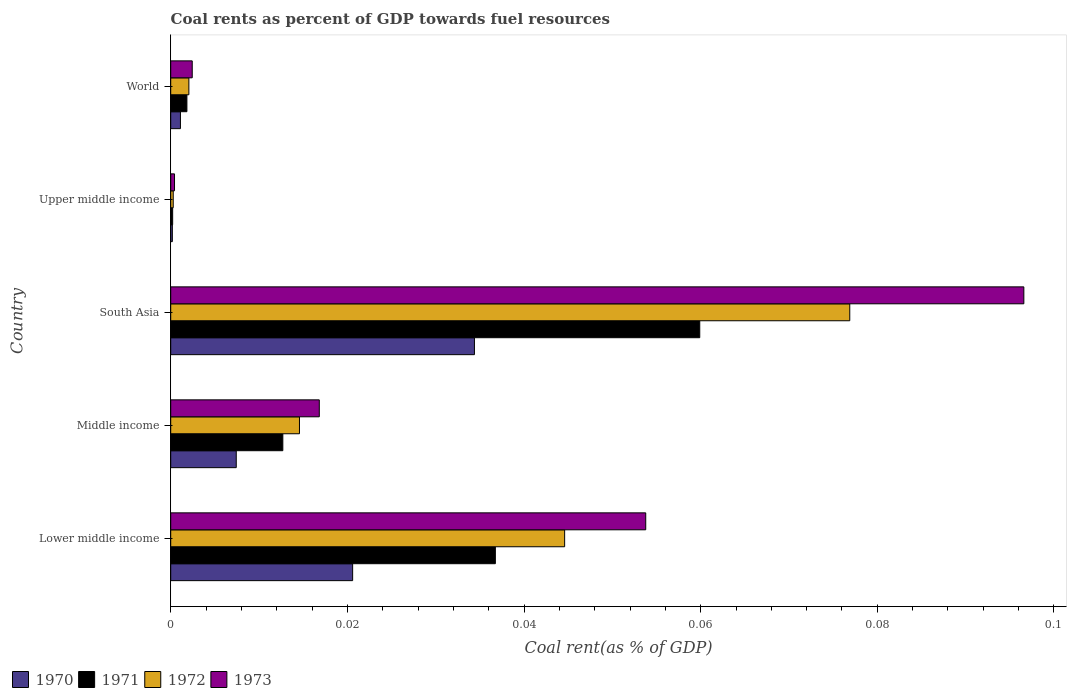How many groups of bars are there?
Ensure brevity in your answer.  5. Are the number of bars per tick equal to the number of legend labels?
Ensure brevity in your answer.  Yes. What is the label of the 4th group of bars from the top?
Offer a terse response. Middle income. In how many cases, is the number of bars for a given country not equal to the number of legend labels?
Keep it short and to the point. 0. What is the coal rent in 1972 in Lower middle income?
Your answer should be very brief. 0.04. Across all countries, what is the maximum coal rent in 1971?
Keep it short and to the point. 0.06. Across all countries, what is the minimum coal rent in 1972?
Your answer should be very brief. 0. In which country was the coal rent in 1973 maximum?
Provide a succinct answer. South Asia. In which country was the coal rent in 1971 minimum?
Offer a terse response. Upper middle income. What is the total coal rent in 1971 in the graph?
Keep it short and to the point. 0.11. What is the difference between the coal rent in 1972 in Lower middle income and that in Upper middle income?
Keep it short and to the point. 0.04. What is the difference between the coal rent in 1971 in World and the coal rent in 1970 in Upper middle income?
Your answer should be very brief. 0. What is the average coal rent in 1973 per country?
Your answer should be compact. 0.03. What is the difference between the coal rent in 1973 and coal rent in 1970 in Lower middle income?
Make the answer very short. 0.03. In how many countries, is the coal rent in 1971 greater than 0.08 %?
Ensure brevity in your answer.  0. What is the ratio of the coal rent in 1972 in Lower middle income to that in Middle income?
Ensure brevity in your answer.  3.06. Is the coal rent in 1973 in South Asia less than that in World?
Offer a very short reply. No. Is the difference between the coal rent in 1973 in South Asia and World greater than the difference between the coal rent in 1970 in South Asia and World?
Give a very brief answer. Yes. What is the difference between the highest and the second highest coal rent in 1971?
Ensure brevity in your answer.  0.02. What is the difference between the highest and the lowest coal rent in 1970?
Keep it short and to the point. 0.03. In how many countries, is the coal rent in 1971 greater than the average coal rent in 1971 taken over all countries?
Give a very brief answer. 2. Is it the case that in every country, the sum of the coal rent in 1970 and coal rent in 1973 is greater than the sum of coal rent in 1971 and coal rent in 1972?
Give a very brief answer. No. What does the 1st bar from the top in South Asia represents?
Your answer should be very brief. 1973. What does the 4th bar from the bottom in Middle income represents?
Your response must be concise. 1973. Is it the case that in every country, the sum of the coal rent in 1971 and coal rent in 1973 is greater than the coal rent in 1972?
Keep it short and to the point. Yes. What is the difference between two consecutive major ticks on the X-axis?
Your answer should be very brief. 0.02. Are the values on the major ticks of X-axis written in scientific E-notation?
Provide a short and direct response. No. Does the graph contain grids?
Offer a terse response. No. What is the title of the graph?
Offer a very short reply. Coal rents as percent of GDP towards fuel resources. What is the label or title of the X-axis?
Give a very brief answer. Coal rent(as % of GDP). What is the Coal rent(as % of GDP) of 1970 in Lower middle income?
Give a very brief answer. 0.02. What is the Coal rent(as % of GDP) of 1971 in Lower middle income?
Offer a terse response. 0.04. What is the Coal rent(as % of GDP) in 1972 in Lower middle income?
Provide a short and direct response. 0.04. What is the Coal rent(as % of GDP) of 1973 in Lower middle income?
Give a very brief answer. 0.05. What is the Coal rent(as % of GDP) of 1970 in Middle income?
Provide a succinct answer. 0.01. What is the Coal rent(as % of GDP) in 1971 in Middle income?
Your response must be concise. 0.01. What is the Coal rent(as % of GDP) in 1972 in Middle income?
Keep it short and to the point. 0.01. What is the Coal rent(as % of GDP) in 1973 in Middle income?
Your response must be concise. 0.02. What is the Coal rent(as % of GDP) of 1970 in South Asia?
Provide a short and direct response. 0.03. What is the Coal rent(as % of GDP) of 1971 in South Asia?
Ensure brevity in your answer.  0.06. What is the Coal rent(as % of GDP) of 1972 in South Asia?
Keep it short and to the point. 0.08. What is the Coal rent(as % of GDP) of 1973 in South Asia?
Give a very brief answer. 0.1. What is the Coal rent(as % of GDP) in 1970 in Upper middle income?
Make the answer very short. 0. What is the Coal rent(as % of GDP) of 1971 in Upper middle income?
Provide a succinct answer. 0. What is the Coal rent(as % of GDP) in 1972 in Upper middle income?
Keep it short and to the point. 0. What is the Coal rent(as % of GDP) in 1973 in Upper middle income?
Give a very brief answer. 0. What is the Coal rent(as % of GDP) in 1970 in World?
Offer a terse response. 0. What is the Coal rent(as % of GDP) of 1971 in World?
Ensure brevity in your answer.  0. What is the Coal rent(as % of GDP) of 1972 in World?
Your response must be concise. 0. What is the Coal rent(as % of GDP) of 1973 in World?
Offer a very short reply. 0. Across all countries, what is the maximum Coal rent(as % of GDP) in 1970?
Provide a succinct answer. 0.03. Across all countries, what is the maximum Coal rent(as % of GDP) in 1971?
Your response must be concise. 0.06. Across all countries, what is the maximum Coal rent(as % of GDP) of 1972?
Your answer should be compact. 0.08. Across all countries, what is the maximum Coal rent(as % of GDP) in 1973?
Make the answer very short. 0.1. Across all countries, what is the minimum Coal rent(as % of GDP) in 1970?
Offer a very short reply. 0. Across all countries, what is the minimum Coal rent(as % of GDP) of 1971?
Offer a very short reply. 0. Across all countries, what is the minimum Coal rent(as % of GDP) in 1972?
Offer a very short reply. 0. Across all countries, what is the minimum Coal rent(as % of GDP) of 1973?
Make the answer very short. 0. What is the total Coal rent(as % of GDP) in 1970 in the graph?
Your response must be concise. 0.06. What is the total Coal rent(as % of GDP) of 1971 in the graph?
Your response must be concise. 0.11. What is the total Coal rent(as % of GDP) of 1972 in the graph?
Your response must be concise. 0.14. What is the total Coal rent(as % of GDP) of 1973 in the graph?
Make the answer very short. 0.17. What is the difference between the Coal rent(as % of GDP) in 1970 in Lower middle income and that in Middle income?
Your response must be concise. 0.01. What is the difference between the Coal rent(as % of GDP) in 1971 in Lower middle income and that in Middle income?
Make the answer very short. 0.02. What is the difference between the Coal rent(as % of GDP) of 1973 in Lower middle income and that in Middle income?
Your answer should be compact. 0.04. What is the difference between the Coal rent(as % of GDP) in 1970 in Lower middle income and that in South Asia?
Offer a very short reply. -0.01. What is the difference between the Coal rent(as % of GDP) in 1971 in Lower middle income and that in South Asia?
Make the answer very short. -0.02. What is the difference between the Coal rent(as % of GDP) in 1972 in Lower middle income and that in South Asia?
Provide a succinct answer. -0.03. What is the difference between the Coal rent(as % of GDP) of 1973 in Lower middle income and that in South Asia?
Give a very brief answer. -0.04. What is the difference between the Coal rent(as % of GDP) of 1970 in Lower middle income and that in Upper middle income?
Give a very brief answer. 0.02. What is the difference between the Coal rent(as % of GDP) in 1971 in Lower middle income and that in Upper middle income?
Make the answer very short. 0.04. What is the difference between the Coal rent(as % of GDP) of 1972 in Lower middle income and that in Upper middle income?
Offer a very short reply. 0.04. What is the difference between the Coal rent(as % of GDP) in 1973 in Lower middle income and that in Upper middle income?
Ensure brevity in your answer.  0.05. What is the difference between the Coal rent(as % of GDP) in 1970 in Lower middle income and that in World?
Offer a terse response. 0.02. What is the difference between the Coal rent(as % of GDP) of 1971 in Lower middle income and that in World?
Offer a terse response. 0.03. What is the difference between the Coal rent(as % of GDP) of 1972 in Lower middle income and that in World?
Your answer should be very brief. 0.04. What is the difference between the Coal rent(as % of GDP) in 1973 in Lower middle income and that in World?
Offer a very short reply. 0.05. What is the difference between the Coal rent(as % of GDP) of 1970 in Middle income and that in South Asia?
Offer a very short reply. -0.03. What is the difference between the Coal rent(as % of GDP) in 1971 in Middle income and that in South Asia?
Offer a very short reply. -0.05. What is the difference between the Coal rent(as % of GDP) in 1972 in Middle income and that in South Asia?
Keep it short and to the point. -0.06. What is the difference between the Coal rent(as % of GDP) in 1973 in Middle income and that in South Asia?
Give a very brief answer. -0.08. What is the difference between the Coal rent(as % of GDP) in 1970 in Middle income and that in Upper middle income?
Provide a short and direct response. 0.01. What is the difference between the Coal rent(as % of GDP) of 1971 in Middle income and that in Upper middle income?
Provide a succinct answer. 0.01. What is the difference between the Coal rent(as % of GDP) of 1972 in Middle income and that in Upper middle income?
Your answer should be compact. 0.01. What is the difference between the Coal rent(as % of GDP) of 1973 in Middle income and that in Upper middle income?
Provide a short and direct response. 0.02. What is the difference between the Coal rent(as % of GDP) in 1970 in Middle income and that in World?
Keep it short and to the point. 0.01. What is the difference between the Coal rent(as % of GDP) in 1971 in Middle income and that in World?
Give a very brief answer. 0.01. What is the difference between the Coal rent(as % of GDP) of 1972 in Middle income and that in World?
Your response must be concise. 0.01. What is the difference between the Coal rent(as % of GDP) of 1973 in Middle income and that in World?
Keep it short and to the point. 0.01. What is the difference between the Coal rent(as % of GDP) in 1970 in South Asia and that in Upper middle income?
Your answer should be very brief. 0.03. What is the difference between the Coal rent(as % of GDP) in 1971 in South Asia and that in Upper middle income?
Offer a very short reply. 0.06. What is the difference between the Coal rent(as % of GDP) in 1972 in South Asia and that in Upper middle income?
Your answer should be very brief. 0.08. What is the difference between the Coal rent(as % of GDP) in 1973 in South Asia and that in Upper middle income?
Provide a succinct answer. 0.1. What is the difference between the Coal rent(as % of GDP) of 1970 in South Asia and that in World?
Provide a short and direct response. 0.03. What is the difference between the Coal rent(as % of GDP) of 1971 in South Asia and that in World?
Offer a very short reply. 0.06. What is the difference between the Coal rent(as % of GDP) in 1972 in South Asia and that in World?
Keep it short and to the point. 0.07. What is the difference between the Coal rent(as % of GDP) in 1973 in South Asia and that in World?
Provide a succinct answer. 0.09. What is the difference between the Coal rent(as % of GDP) of 1970 in Upper middle income and that in World?
Your answer should be very brief. -0. What is the difference between the Coal rent(as % of GDP) of 1971 in Upper middle income and that in World?
Your answer should be very brief. -0. What is the difference between the Coal rent(as % of GDP) of 1972 in Upper middle income and that in World?
Offer a terse response. -0. What is the difference between the Coal rent(as % of GDP) of 1973 in Upper middle income and that in World?
Keep it short and to the point. -0. What is the difference between the Coal rent(as % of GDP) in 1970 in Lower middle income and the Coal rent(as % of GDP) in 1971 in Middle income?
Provide a succinct answer. 0.01. What is the difference between the Coal rent(as % of GDP) in 1970 in Lower middle income and the Coal rent(as % of GDP) in 1972 in Middle income?
Keep it short and to the point. 0.01. What is the difference between the Coal rent(as % of GDP) of 1970 in Lower middle income and the Coal rent(as % of GDP) of 1973 in Middle income?
Offer a terse response. 0. What is the difference between the Coal rent(as % of GDP) of 1971 in Lower middle income and the Coal rent(as % of GDP) of 1972 in Middle income?
Provide a succinct answer. 0.02. What is the difference between the Coal rent(as % of GDP) of 1971 in Lower middle income and the Coal rent(as % of GDP) of 1973 in Middle income?
Ensure brevity in your answer.  0.02. What is the difference between the Coal rent(as % of GDP) of 1972 in Lower middle income and the Coal rent(as % of GDP) of 1973 in Middle income?
Give a very brief answer. 0.03. What is the difference between the Coal rent(as % of GDP) in 1970 in Lower middle income and the Coal rent(as % of GDP) in 1971 in South Asia?
Ensure brevity in your answer.  -0.04. What is the difference between the Coal rent(as % of GDP) of 1970 in Lower middle income and the Coal rent(as % of GDP) of 1972 in South Asia?
Offer a terse response. -0.06. What is the difference between the Coal rent(as % of GDP) in 1970 in Lower middle income and the Coal rent(as % of GDP) in 1973 in South Asia?
Provide a short and direct response. -0.08. What is the difference between the Coal rent(as % of GDP) in 1971 in Lower middle income and the Coal rent(as % of GDP) in 1972 in South Asia?
Ensure brevity in your answer.  -0.04. What is the difference between the Coal rent(as % of GDP) in 1971 in Lower middle income and the Coal rent(as % of GDP) in 1973 in South Asia?
Give a very brief answer. -0.06. What is the difference between the Coal rent(as % of GDP) in 1972 in Lower middle income and the Coal rent(as % of GDP) in 1973 in South Asia?
Your answer should be compact. -0.05. What is the difference between the Coal rent(as % of GDP) in 1970 in Lower middle income and the Coal rent(as % of GDP) in 1971 in Upper middle income?
Your response must be concise. 0.02. What is the difference between the Coal rent(as % of GDP) of 1970 in Lower middle income and the Coal rent(as % of GDP) of 1972 in Upper middle income?
Provide a succinct answer. 0.02. What is the difference between the Coal rent(as % of GDP) of 1970 in Lower middle income and the Coal rent(as % of GDP) of 1973 in Upper middle income?
Your answer should be compact. 0.02. What is the difference between the Coal rent(as % of GDP) of 1971 in Lower middle income and the Coal rent(as % of GDP) of 1972 in Upper middle income?
Your answer should be compact. 0.04. What is the difference between the Coal rent(as % of GDP) in 1971 in Lower middle income and the Coal rent(as % of GDP) in 1973 in Upper middle income?
Your answer should be very brief. 0.04. What is the difference between the Coal rent(as % of GDP) of 1972 in Lower middle income and the Coal rent(as % of GDP) of 1973 in Upper middle income?
Your answer should be compact. 0.04. What is the difference between the Coal rent(as % of GDP) in 1970 in Lower middle income and the Coal rent(as % of GDP) in 1971 in World?
Provide a succinct answer. 0.02. What is the difference between the Coal rent(as % of GDP) in 1970 in Lower middle income and the Coal rent(as % of GDP) in 1972 in World?
Provide a short and direct response. 0.02. What is the difference between the Coal rent(as % of GDP) in 1970 in Lower middle income and the Coal rent(as % of GDP) in 1973 in World?
Provide a short and direct response. 0.02. What is the difference between the Coal rent(as % of GDP) in 1971 in Lower middle income and the Coal rent(as % of GDP) in 1972 in World?
Make the answer very short. 0.03. What is the difference between the Coal rent(as % of GDP) of 1971 in Lower middle income and the Coal rent(as % of GDP) of 1973 in World?
Provide a short and direct response. 0.03. What is the difference between the Coal rent(as % of GDP) of 1972 in Lower middle income and the Coal rent(as % of GDP) of 1973 in World?
Keep it short and to the point. 0.04. What is the difference between the Coal rent(as % of GDP) in 1970 in Middle income and the Coal rent(as % of GDP) in 1971 in South Asia?
Offer a terse response. -0.05. What is the difference between the Coal rent(as % of GDP) in 1970 in Middle income and the Coal rent(as % of GDP) in 1972 in South Asia?
Your answer should be very brief. -0.07. What is the difference between the Coal rent(as % of GDP) in 1970 in Middle income and the Coal rent(as % of GDP) in 1973 in South Asia?
Make the answer very short. -0.09. What is the difference between the Coal rent(as % of GDP) of 1971 in Middle income and the Coal rent(as % of GDP) of 1972 in South Asia?
Keep it short and to the point. -0.06. What is the difference between the Coal rent(as % of GDP) of 1971 in Middle income and the Coal rent(as % of GDP) of 1973 in South Asia?
Keep it short and to the point. -0.08. What is the difference between the Coal rent(as % of GDP) in 1972 in Middle income and the Coal rent(as % of GDP) in 1973 in South Asia?
Ensure brevity in your answer.  -0.08. What is the difference between the Coal rent(as % of GDP) in 1970 in Middle income and the Coal rent(as % of GDP) in 1971 in Upper middle income?
Provide a short and direct response. 0.01. What is the difference between the Coal rent(as % of GDP) of 1970 in Middle income and the Coal rent(as % of GDP) of 1972 in Upper middle income?
Offer a very short reply. 0.01. What is the difference between the Coal rent(as % of GDP) in 1970 in Middle income and the Coal rent(as % of GDP) in 1973 in Upper middle income?
Keep it short and to the point. 0.01. What is the difference between the Coal rent(as % of GDP) in 1971 in Middle income and the Coal rent(as % of GDP) in 1972 in Upper middle income?
Ensure brevity in your answer.  0.01. What is the difference between the Coal rent(as % of GDP) of 1971 in Middle income and the Coal rent(as % of GDP) of 1973 in Upper middle income?
Your response must be concise. 0.01. What is the difference between the Coal rent(as % of GDP) in 1972 in Middle income and the Coal rent(as % of GDP) in 1973 in Upper middle income?
Provide a succinct answer. 0.01. What is the difference between the Coal rent(as % of GDP) in 1970 in Middle income and the Coal rent(as % of GDP) in 1971 in World?
Your answer should be compact. 0.01. What is the difference between the Coal rent(as % of GDP) in 1970 in Middle income and the Coal rent(as % of GDP) in 1972 in World?
Your answer should be compact. 0.01. What is the difference between the Coal rent(as % of GDP) in 1970 in Middle income and the Coal rent(as % of GDP) in 1973 in World?
Keep it short and to the point. 0.01. What is the difference between the Coal rent(as % of GDP) of 1971 in Middle income and the Coal rent(as % of GDP) of 1972 in World?
Provide a succinct answer. 0.01. What is the difference between the Coal rent(as % of GDP) in 1971 in Middle income and the Coal rent(as % of GDP) in 1973 in World?
Give a very brief answer. 0.01. What is the difference between the Coal rent(as % of GDP) of 1972 in Middle income and the Coal rent(as % of GDP) of 1973 in World?
Your answer should be very brief. 0.01. What is the difference between the Coal rent(as % of GDP) of 1970 in South Asia and the Coal rent(as % of GDP) of 1971 in Upper middle income?
Your response must be concise. 0.03. What is the difference between the Coal rent(as % of GDP) of 1970 in South Asia and the Coal rent(as % of GDP) of 1972 in Upper middle income?
Your answer should be compact. 0.03. What is the difference between the Coal rent(as % of GDP) of 1970 in South Asia and the Coal rent(as % of GDP) of 1973 in Upper middle income?
Offer a very short reply. 0.03. What is the difference between the Coal rent(as % of GDP) of 1971 in South Asia and the Coal rent(as % of GDP) of 1972 in Upper middle income?
Ensure brevity in your answer.  0.06. What is the difference between the Coal rent(as % of GDP) in 1971 in South Asia and the Coal rent(as % of GDP) in 1973 in Upper middle income?
Keep it short and to the point. 0.06. What is the difference between the Coal rent(as % of GDP) in 1972 in South Asia and the Coal rent(as % of GDP) in 1973 in Upper middle income?
Offer a very short reply. 0.08. What is the difference between the Coal rent(as % of GDP) in 1970 in South Asia and the Coal rent(as % of GDP) in 1971 in World?
Your response must be concise. 0.03. What is the difference between the Coal rent(as % of GDP) of 1970 in South Asia and the Coal rent(as % of GDP) of 1972 in World?
Ensure brevity in your answer.  0.03. What is the difference between the Coal rent(as % of GDP) in 1970 in South Asia and the Coal rent(as % of GDP) in 1973 in World?
Ensure brevity in your answer.  0.03. What is the difference between the Coal rent(as % of GDP) in 1971 in South Asia and the Coal rent(as % of GDP) in 1972 in World?
Keep it short and to the point. 0.06. What is the difference between the Coal rent(as % of GDP) of 1971 in South Asia and the Coal rent(as % of GDP) of 1973 in World?
Ensure brevity in your answer.  0.06. What is the difference between the Coal rent(as % of GDP) of 1972 in South Asia and the Coal rent(as % of GDP) of 1973 in World?
Provide a succinct answer. 0.07. What is the difference between the Coal rent(as % of GDP) of 1970 in Upper middle income and the Coal rent(as % of GDP) of 1971 in World?
Your answer should be very brief. -0. What is the difference between the Coal rent(as % of GDP) of 1970 in Upper middle income and the Coal rent(as % of GDP) of 1972 in World?
Keep it short and to the point. -0. What is the difference between the Coal rent(as % of GDP) of 1970 in Upper middle income and the Coal rent(as % of GDP) of 1973 in World?
Your response must be concise. -0. What is the difference between the Coal rent(as % of GDP) in 1971 in Upper middle income and the Coal rent(as % of GDP) in 1972 in World?
Make the answer very short. -0. What is the difference between the Coal rent(as % of GDP) of 1971 in Upper middle income and the Coal rent(as % of GDP) of 1973 in World?
Provide a succinct answer. -0. What is the difference between the Coal rent(as % of GDP) of 1972 in Upper middle income and the Coal rent(as % of GDP) of 1973 in World?
Give a very brief answer. -0. What is the average Coal rent(as % of GDP) of 1970 per country?
Ensure brevity in your answer.  0.01. What is the average Coal rent(as % of GDP) in 1971 per country?
Make the answer very short. 0.02. What is the average Coal rent(as % of GDP) in 1972 per country?
Your answer should be compact. 0.03. What is the average Coal rent(as % of GDP) of 1973 per country?
Keep it short and to the point. 0.03. What is the difference between the Coal rent(as % of GDP) of 1970 and Coal rent(as % of GDP) of 1971 in Lower middle income?
Offer a terse response. -0.02. What is the difference between the Coal rent(as % of GDP) in 1970 and Coal rent(as % of GDP) in 1972 in Lower middle income?
Provide a short and direct response. -0.02. What is the difference between the Coal rent(as % of GDP) of 1970 and Coal rent(as % of GDP) of 1973 in Lower middle income?
Make the answer very short. -0.03. What is the difference between the Coal rent(as % of GDP) in 1971 and Coal rent(as % of GDP) in 1972 in Lower middle income?
Provide a succinct answer. -0.01. What is the difference between the Coal rent(as % of GDP) in 1971 and Coal rent(as % of GDP) in 1973 in Lower middle income?
Give a very brief answer. -0.02. What is the difference between the Coal rent(as % of GDP) in 1972 and Coal rent(as % of GDP) in 1973 in Lower middle income?
Your answer should be very brief. -0.01. What is the difference between the Coal rent(as % of GDP) in 1970 and Coal rent(as % of GDP) in 1971 in Middle income?
Ensure brevity in your answer.  -0.01. What is the difference between the Coal rent(as % of GDP) in 1970 and Coal rent(as % of GDP) in 1972 in Middle income?
Give a very brief answer. -0.01. What is the difference between the Coal rent(as % of GDP) in 1970 and Coal rent(as % of GDP) in 1973 in Middle income?
Give a very brief answer. -0.01. What is the difference between the Coal rent(as % of GDP) in 1971 and Coal rent(as % of GDP) in 1972 in Middle income?
Offer a terse response. -0. What is the difference between the Coal rent(as % of GDP) in 1971 and Coal rent(as % of GDP) in 1973 in Middle income?
Offer a terse response. -0. What is the difference between the Coal rent(as % of GDP) in 1972 and Coal rent(as % of GDP) in 1973 in Middle income?
Provide a short and direct response. -0. What is the difference between the Coal rent(as % of GDP) of 1970 and Coal rent(as % of GDP) of 1971 in South Asia?
Your response must be concise. -0.03. What is the difference between the Coal rent(as % of GDP) of 1970 and Coal rent(as % of GDP) of 1972 in South Asia?
Keep it short and to the point. -0.04. What is the difference between the Coal rent(as % of GDP) in 1970 and Coal rent(as % of GDP) in 1973 in South Asia?
Offer a terse response. -0.06. What is the difference between the Coal rent(as % of GDP) in 1971 and Coal rent(as % of GDP) in 1972 in South Asia?
Ensure brevity in your answer.  -0.02. What is the difference between the Coal rent(as % of GDP) of 1971 and Coal rent(as % of GDP) of 1973 in South Asia?
Your answer should be very brief. -0.04. What is the difference between the Coal rent(as % of GDP) in 1972 and Coal rent(as % of GDP) in 1973 in South Asia?
Make the answer very short. -0.02. What is the difference between the Coal rent(as % of GDP) in 1970 and Coal rent(as % of GDP) in 1971 in Upper middle income?
Offer a very short reply. -0. What is the difference between the Coal rent(as % of GDP) of 1970 and Coal rent(as % of GDP) of 1972 in Upper middle income?
Your response must be concise. -0. What is the difference between the Coal rent(as % of GDP) of 1970 and Coal rent(as % of GDP) of 1973 in Upper middle income?
Provide a short and direct response. -0. What is the difference between the Coal rent(as % of GDP) in 1971 and Coal rent(as % of GDP) in 1972 in Upper middle income?
Keep it short and to the point. -0. What is the difference between the Coal rent(as % of GDP) in 1971 and Coal rent(as % of GDP) in 1973 in Upper middle income?
Your response must be concise. -0. What is the difference between the Coal rent(as % of GDP) of 1972 and Coal rent(as % of GDP) of 1973 in Upper middle income?
Your answer should be compact. -0. What is the difference between the Coal rent(as % of GDP) in 1970 and Coal rent(as % of GDP) in 1971 in World?
Give a very brief answer. -0. What is the difference between the Coal rent(as % of GDP) of 1970 and Coal rent(as % of GDP) of 1972 in World?
Your answer should be very brief. -0. What is the difference between the Coal rent(as % of GDP) in 1970 and Coal rent(as % of GDP) in 1973 in World?
Make the answer very short. -0. What is the difference between the Coal rent(as % of GDP) in 1971 and Coal rent(as % of GDP) in 1972 in World?
Keep it short and to the point. -0. What is the difference between the Coal rent(as % of GDP) of 1971 and Coal rent(as % of GDP) of 1973 in World?
Keep it short and to the point. -0. What is the difference between the Coal rent(as % of GDP) of 1972 and Coal rent(as % of GDP) of 1973 in World?
Offer a very short reply. -0. What is the ratio of the Coal rent(as % of GDP) in 1970 in Lower middle income to that in Middle income?
Provide a succinct answer. 2.78. What is the ratio of the Coal rent(as % of GDP) in 1971 in Lower middle income to that in Middle income?
Your response must be concise. 2.9. What is the ratio of the Coal rent(as % of GDP) of 1972 in Lower middle income to that in Middle income?
Your response must be concise. 3.06. What is the ratio of the Coal rent(as % of GDP) of 1973 in Lower middle income to that in Middle income?
Give a very brief answer. 3.2. What is the ratio of the Coal rent(as % of GDP) in 1970 in Lower middle income to that in South Asia?
Offer a terse response. 0.6. What is the ratio of the Coal rent(as % of GDP) in 1971 in Lower middle income to that in South Asia?
Offer a very short reply. 0.61. What is the ratio of the Coal rent(as % of GDP) of 1972 in Lower middle income to that in South Asia?
Make the answer very short. 0.58. What is the ratio of the Coal rent(as % of GDP) of 1973 in Lower middle income to that in South Asia?
Offer a terse response. 0.56. What is the ratio of the Coal rent(as % of GDP) of 1970 in Lower middle income to that in Upper middle income?
Your response must be concise. 112.03. What is the ratio of the Coal rent(as % of GDP) in 1971 in Lower middle income to that in Upper middle income?
Keep it short and to the point. 167.98. What is the ratio of the Coal rent(as % of GDP) in 1972 in Lower middle income to that in Upper middle income?
Your answer should be very brief. 156.82. What is the ratio of the Coal rent(as % of GDP) of 1973 in Lower middle income to that in Upper middle income?
Ensure brevity in your answer.  124.82. What is the ratio of the Coal rent(as % of GDP) in 1970 in Lower middle income to that in World?
Ensure brevity in your answer.  18.71. What is the ratio of the Coal rent(as % of GDP) of 1971 in Lower middle income to that in World?
Provide a succinct answer. 20.06. What is the ratio of the Coal rent(as % of GDP) in 1972 in Lower middle income to that in World?
Offer a very short reply. 21.7. What is the ratio of the Coal rent(as % of GDP) in 1973 in Lower middle income to that in World?
Keep it short and to the point. 22.07. What is the ratio of the Coal rent(as % of GDP) in 1970 in Middle income to that in South Asia?
Offer a very short reply. 0.22. What is the ratio of the Coal rent(as % of GDP) in 1971 in Middle income to that in South Asia?
Your response must be concise. 0.21. What is the ratio of the Coal rent(as % of GDP) in 1972 in Middle income to that in South Asia?
Your answer should be very brief. 0.19. What is the ratio of the Coal rent(as % of GDP) of 1973 in Middle income to that in South Asia?
Make the answer very short. 0.17. What is the ratio of the Coal rent(as % of GDP) in 1970 in Middle income to that in Upper middle income?
Provide a succinct answer. 40.36. What is the ratio of the Coal rent(as % of GDP) in 1971 in Middle income to that in Upper middle income?
Your answer should be very brief. 58.01. What is the ratio of the Coal rent(as % of GDP) of 1972 in Middle income to that in Upper middle income?
Provide a succinct answer. 51.25. What is the ratio of the Coal rent(as % of GDP) in 1973 in Middle income to that in Upper middle income?
Offer a very short reply. 39.04. What is the ratio of the Coal rent(as % of GDP) of 1970 in Middle income to that in World?
Ensure brevity in your answer.  6.74. What is the ratio of the Coal rent(as % of GDP) of 1971 in Middle income to that in World?
Provide a succinct answer. 6.93. What is the ratio of the Coal rent(as % of GDP) of 1972 in Middle income to that in World?
Your answer should be very brief. 7.09. What is the ratio of the Coal rent(as % of GDP) of 1973 in Middle income to that in World?
Make the answer very short. 6.91. What is the ratio of the Coal rent(as % of GDP) of 1970 in South Asia to that in Upper middle income?
Make the answer very short. 187.05. What is the ratio of the Coal rent(as % of GDP) in 1971 in South Asia to that in Upper middle income?
Your answer should be compact. 273.74. What is the ratio of the Coal rent(as % of GDP) of 1972 in South Asia to that in Upper middle income?
Make the answer very short. 270.32. What is the ratio of the Coal rent(as % of GDP) of 1973 in South Asia to that in Upper middle income?
Make the answer very short. 224.18. What is the ratio of the Coal rent(as % of GDP) in 1970 in South Asia to that in World?
Your answer should be compact. 31.24. What is the ratio of the Coal rent(as % of GDP) of 1971 in South Asia to that in World?
Offer a very short reply. 32.69. What is the ratio of the Coal rent(as % of GDP) of 1972 in South Asia to that in World?
Offer a terse response. 37.41. What is the ratio of the Coal rent(as % of GDP) in 1973 in South Asia to that in World?
Your answer should be very brief. 39.65. What is the ratio of the Coal rent(as % of GDP) of 1970 in Upper middle income to that in World?
Give a very brief answer. 0.17. What is the ratio of the Coal rent(as % of GDP) of 1971 in Upper middle income to that in World?
Provide a succinct answer. 0.12. What is the ratio of the Coal rent(as % of GDP) in 1972 in Upper middle income to that in World?
Your answer should be very brief. 0.14. What is the ratio of the Coal rent(as % of GDP) in 1973 in Upper middle income to that in World?
Provide a succinct answer. 0.18. What is the difference between the highest and the second highest Coal rent(as % of GDP) of 1970?
Your answer should be compact. 0.01. What is the difference between the highest and the second highest Coal rent(as % of GDP) of 1971?
Make the answer very short. 0.02. What is the difference between the highest and the second highest Coal rent(as % of GDP) of 1972?
Ensure brevity in your answer.  0.03. What is the difference between the highest and the second highest Coal rent(as % of GDP) of 1973?
Provide a short and direct response. 0.04. What is the difference between the highest and the lowest Coal rent(as % of GDP) of 1970?
Provide a short and direct response. 0.03. What is the difference between the highest and the lowest Coal rent(as % of GDP) of 1971?
Provide a succinct answer. 0.06. What is the difference between the highest and the lowest Coal rent(as % of GDP) of 1972?
Provide a succinct answer. 0.08. What is the difference between the highest and the lowest Coal rent(as % of GDP) in 1973?
Provide a short and direct response. 0.1. 